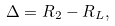<formula> <loc_0><loc_0><loc_500><loc_500>\Delta = R _ { 2 } - R _ { L } ,</formula> 